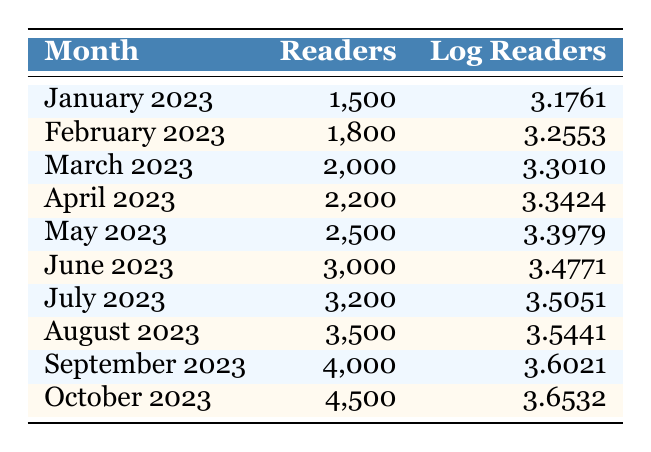What was the number of readers in June 2023? The table states that in June 2023, there were 3,000 readers listed.
Answer: 3,000 What is the logarithmic value of readers for February 2023? According to the table, the logarithmic value for February 2023 is 3.2553.
Answer: 3.2553 Which month recorded the highest number of readers? By reviewing the 'Readers' column, October 2023 has the highest value with 4,500 readers.
Answer: October 2023 What is the total number of readers from March to May 2023? Adding the number of readers from March (2,000), April (2,200), and May (2,500) gives: 2,000 + 2,200 + 2,500 = 6,700.
Answer: 6,700 Is the logarithmic reader value for July greater than that for January? By comparing the values, July 2023 has a logarithmic value of 3.5051, while January 2023 has a value of 3.1761. Therefore, yes, the value for July is greater.
Answer: Yes What is the average number of readers for the months of August and September 2023? The number of readers for August is 3,500 and for September is 4,000. Calculating the average: (3,500 + 4,000) / 2 = 3,750.
Answer: 3,750 In which month was there a decrease in readership compared to the previous month? Reviewing the table shows continual increases month-over-month; therefore, no month presents a decrease.
Answer: No What is the difference in logarithmic values between the readers in October and January 2023? The logarithmic value in October is 3.6532 and in January is 3.1761. The difference is calculated as: 3.6532 - 3.1761 = 0.4771.
Answer: 0.4771 Which month had the least readership? According to the table, January 2023 reported the least readership with 1,500 readers.
Answer: January 2023 